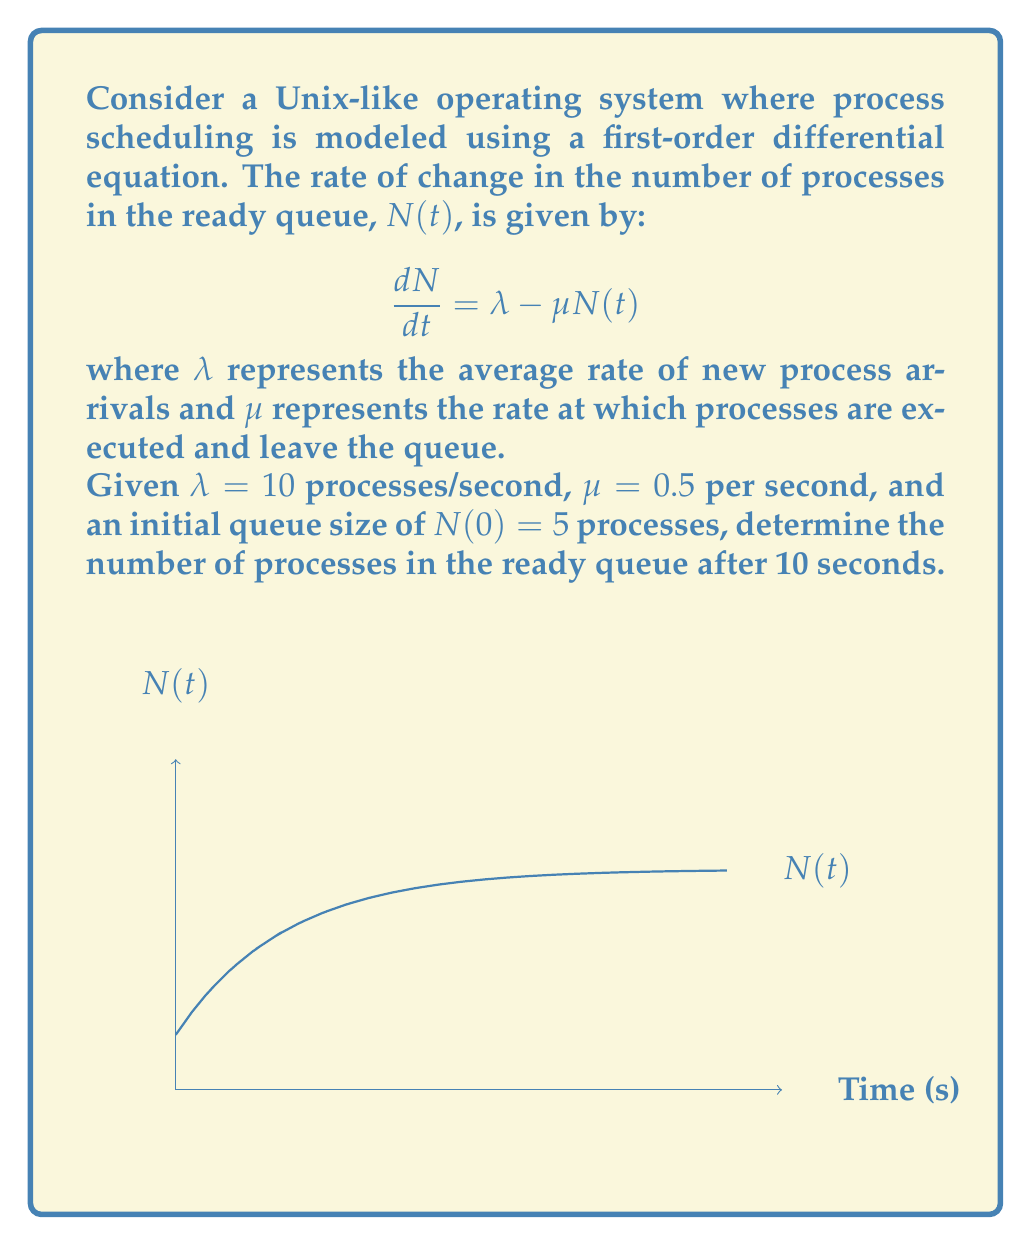Help me with this question. To solve this problem, we need to follow these steps:

1) The given differential equation is of the form:
   $$\frac{dN}{dt} = \lambda - \mu N(t)$$

2) This is a first-order linear differential equation. The general solution is:
   $$N(t) = \frac{\lambda}{\mu} + Ce^{-\mu t}$$
   where $C$ is a constant determined by the initial condition.

3) We're given:
   $\lambda = 10$ processes/second
   $\mu = 0.5$ per second
   $N(0) = 5$ processes

4) Substituting $\lambda$ and $\mu$ into the general solution:
   $$N(t) = \frac{10}{0.5} + Ce^{-0.5t} = 20 + Ce^{-0.5t}$$

5) Using the initial condition $N(0) = 5$:
   $$5 = 20 + C$$
   $$C = -15$$

6) Therefore, the particular solution is:
   $$N(t) = 20 - 15e^{-0.5t}$$

7) To find $N(10)$, we substitute $t = 10$:
   $$N(10) = 20 - 15e^{-0.5(10)} = 20 - 15e^{-5}$$

8) Calculating this value:
   $$N(10) = 20 - 15(0.00673) \approx 19.90$$

Thus, after 10 seconds, there will be approximately 19.90 processes in the ready queue.
Answer: 19.90 processes 